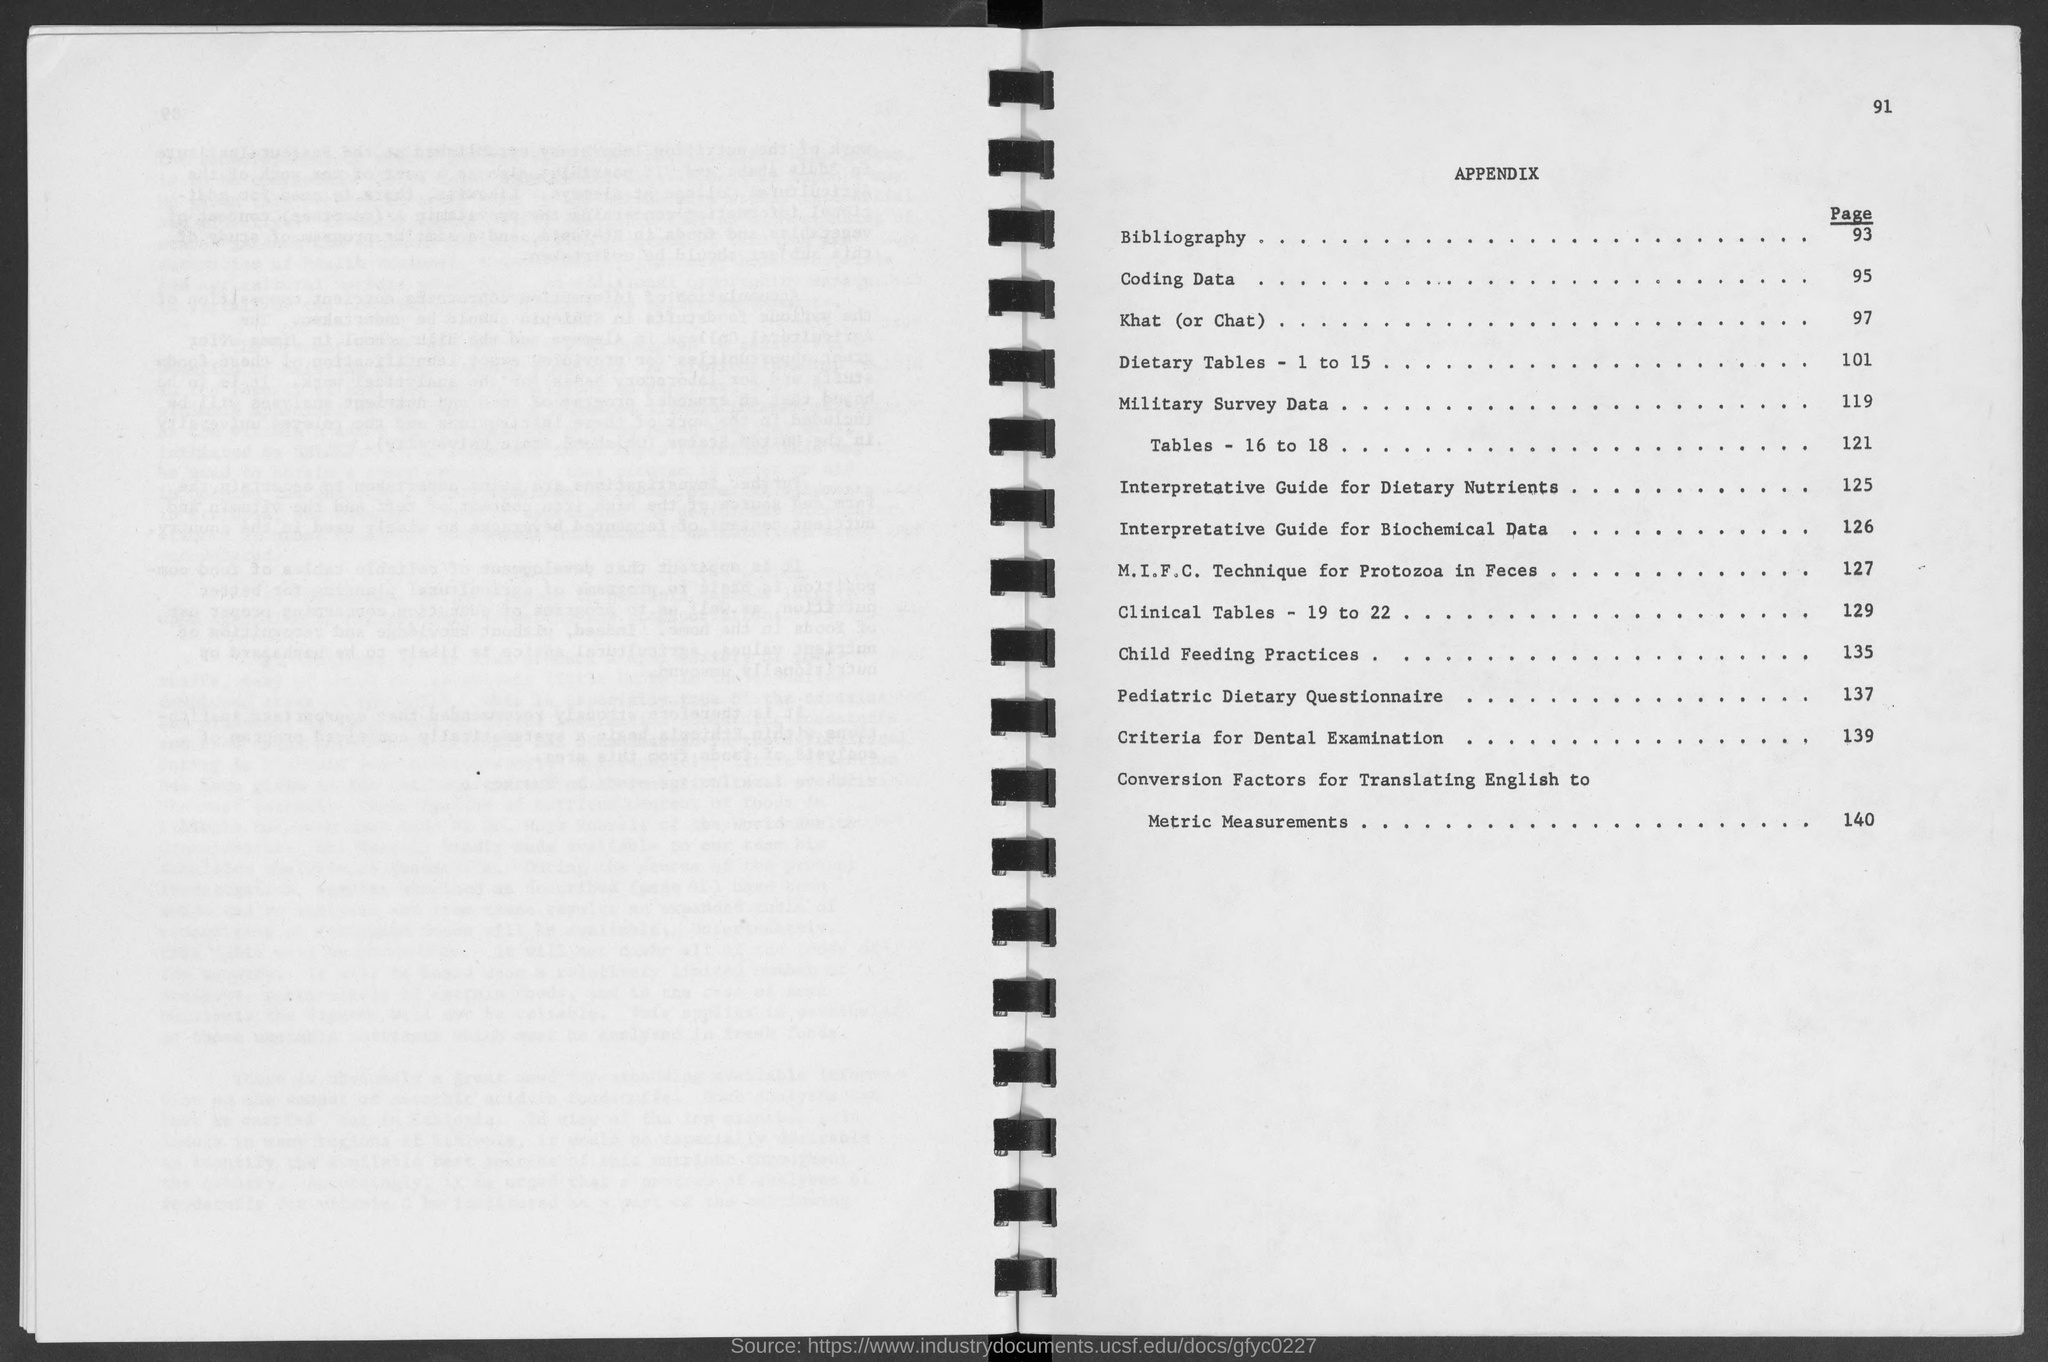What is the number at top-right corner of the page?
Your answer should be very brief. 91. What is the heading of the page ?
Offer a terse response. Appendix. What is the bibliography page no.?
Your answer should be compact. 93. What is the page number of coding data ?
Make the answer very short. 95. What is the page number of khat (or chat) ?
Offer a terse response. 97. What is the page number of conversion factors for translating english to metric measurements?
Offer a very short reply. 140. What is the page number of criteria for dental examination ?
Make the answer very short. 139. What is the page number of pediatric dietary questionnaire ?
Keep it short and to the point. 137. What is the page number of military survey data ?
Offer a very short reply. 119. What is the page number of child feeding practices ?
Ensure brevity in your answer.  135. 